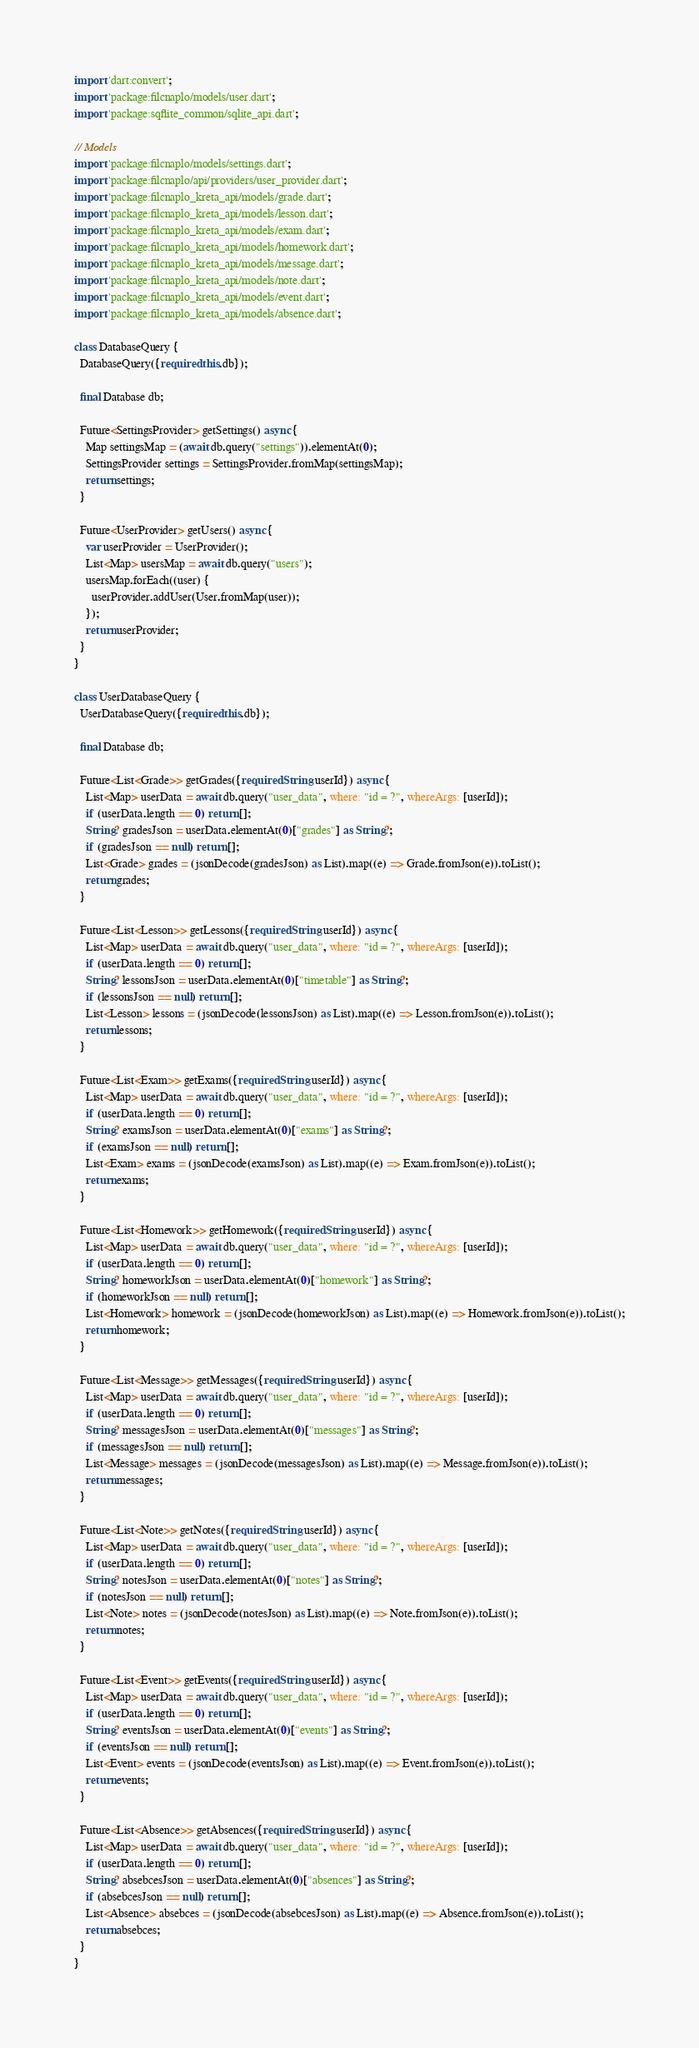<code> <loc_0><loc_0><loc_500><loc_500><_Dart_>import 'dart:convert';
import 'package:filcnaplo/models/user.dart';
import 'package:sqflite_common/sqlite_api.dart';

// Models
import 'package:filcnaplo/models/settings.dart';
import 'package:filcnaplo/api/providers/user_provider.dart';
import 'package:filcnaplo_kreta_api/models/grade.dart';
import 'package:filcnaplo_kreta_api/models/lesson.dart';
import 'package:filcnaplo_kreta_api/models/exam.dart';
import 'package:filcnaplo_kreta_api/models/homework.dart';
import 'package:filcnaplo_kreta_api/models/message.dart';
import 'package:filcnaplo_kreta_api/models/note.dart';
import 'package:filcnaplo_kreta_api/models/event.dart';
import 'package:filcnaplo_kreta_api/models/absence.dart';

class DatabaseQuery {
  DatabaseQuery({required this.db});

  final Database db;

  Future<SettingsProvider> getSettings() async {
    Map settingsMap = (await db.query("settings")).elementAt(0);
    SettingsProvider settings = SettingsProvider.fromMap(settingsMap);
    return settings;
  }

  Future<UserProvider> getUsers() async {
    var userProvider = UserProvider();
    List<Map> usersMap = await db.query("users");
    usersMap.forEach((user) {
      userProvider.addUser(User.fromMap(user));
    });
    return userProvider;
  }
}

class UserDatabaseQuery {
  UserDatabaseQuery({required this.db});

  final Database db;

  Future<List<Grade>> getGrades({required String userId}) async {
    List<Map> userData = await db.query("user_data", where: "id = ?", whereArgs: [userId]);
    if (userData.length == 0) return [];
    String? gradesJson = userData.elementAt(0)["grades"] as String?;
    if (gradesJson == null) return [];
    List<Grade> grades = (jsonDecode(gradesJson) as List).map((e) => Grade.fromJson(e)).toList();
    return grades;
  }

  Future<List<Lesson>> getLessons({required String userId}) async {
    List<Map> userData = await db.query("user_data", where: "id = ?", whereArgs: [userId]);
    if (userData.length == 0) return [];
    String? lessonsJson = userData.elementAt(0)["timetable"] as String?;
    if (lessonsJson == null) return [];
    List<Lesson> lessons = (jsonDecode(lessonsJson) as List).map((e) => Lesson.fromJson(e)).toList();
    return lessons;
  }

  Future<List<Exam>> getExams({required String userId}) async {
    List<Map> userData = await db.query("user_data", where: "id = ?", whereArgs: [userId]);
    if (userData.length == 0) return [];
    String? examsJson = userData.elementAt(0)["exams"] as String?;
    if (examsJson == null) return [];
    List<Exam> exams = (jsonDecode(examsJson) as List).map((e) => Exam.fromJson(e)).toList();
    return exams;
  }

  Future<List<Homework>> getHomework({required String userId}) async {
    List<Map> userData = await db.query("user_data", where: "id = ?", whereArgs: [userId]);
    if (userData.length == 0) return [];
    String? homeworkJson = userData.elementAt(0)["homework"] as String?;
    if (homeworkJson == null) return [];
    List<Homework> homework = (jsonDecode(homeworkJson) as List).map((e) => Homework.fromJson(e)).toList();
    return homework;
  }

  Future<List<Message>> getMessages({required String userId}) async {
    List<Map> userData = await db.query("user_data", where: "id = ?", whereArgs: [userId]);
    if (userData.length == 0) return [];
    String? messagesJson = userData.elementAt(0)["messages"] as String?;
    if (messagesJson == null) return [];
    List<Message> messages = (jsonDecode(messagesJson) as List).map((e) => Message.fromJson(e)).toList();
    return messages;
  }

  Future<List<Note>> getNotes({required String userId}) async {
    List<Map> userData = await db.query("user_data", where: "id = ?", whereArgs: [userId]);
    if (userData.length == 0) return [];
    String? notesJson = userData.elementAt(0)["notes"] as String?;
    if (notesJson == null) return [];
    List<Note> notes = (jsonDecode(notesJson) as List).map((e) => Note.fromJson(e)).toList();
    return notes;
  }

  Future<List<Event>> getEvents({required String userId}) async {
    List<Map> userData = await db.query("user_data", where: "id = ?", whereArgs: [userId]);
    if (userData.length == 0) return [];
    String? eventsJson = userData.elementAt(0)["events"] as String?;
    if (eventsJson == null) return [];
    List<Event> events = (jsonDecode(eventsJson) as List).map((e) => Event.fromJson(e)).toList();
    return events;
  }

  Future<List<Absence>> getAbsences({required String userId}) async {
    List<Map> userData = await db.query("user_data", where: "id = ?", whereArgs: [userId]);
    if (userData.length == 0) return [];
    String? absebcesJson = userData.elementAt(0)["absences"] as String?;
    if (absebcesJson == null) return [];
    List<Absence> absebces = (jsonDecode(absebcesJson) as List).map((e) => Absence.fromJson(e)).toList();
    return absebces;
  }
}
</code> 